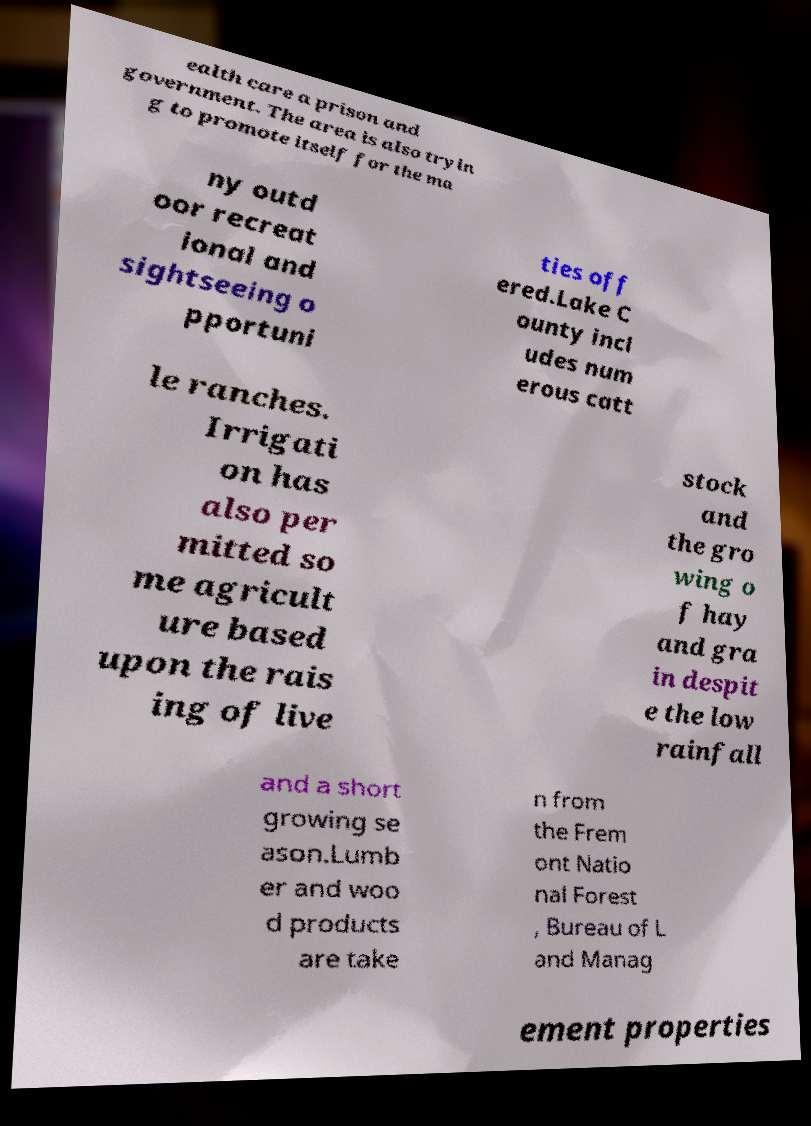There's text embedded in this image that I need extracted. Can you transcribe it verbatim? ealth care a prison and government. The area is also tryin g to promote itself for the ma ny outd oor recreat ional and sightseeing o pportuni ties off ered.Lake C ounty incl udes num erous catt le ranches. Irrigati on has also per mitted so me agricult ure based upon the rais ing of live stock and the gro wing o f hay and gra in despit e the low rainfall and a short growing se ason.Lumb er and woo d products are take n from the Frem ont Natio nal Forest , Bureau of L and Manag ement properties 